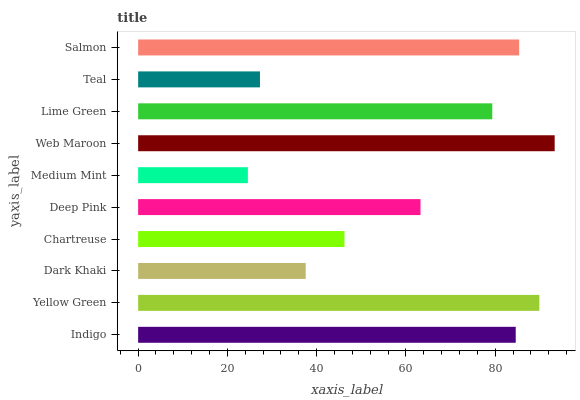Is Medium Mint the minimum?
Answer yes or no. Yes. Is Web Maroon the maximum?
Answer yes or no. Yes. Is Yellow Green the minimum?
Answer yes or no. No. Is Yellow Green the maximum?
Answer yes or no. No. Is Yellow Green greater than Indigo?
Answer yes or no. Yes. Is Indigo less than Yellow Green?
Answer yes or no. Yes. Is Indigo greater than Yellow Green?
Answer yes or no. No. Is Yellow Green less than Indigo?
Answer yes or no. No. Is Lime Green the high median?
Answer yes or no. Yes. Is Deep Pink the low median?
Answer yes or no. Yes. Is Deep Pink the high median?
Answer yes or no. No. Is Web Maroon the low median?
Answer yes or no. No. 